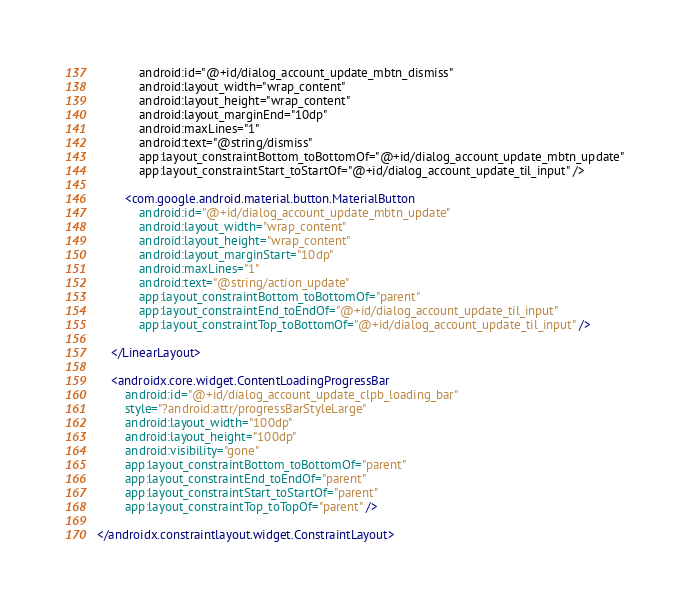Convert code to text. <code><loc_0><loc_0><loc_500><loc_500><_XML_>            android:id="@+id/dialog_account_update_mbtn_dismiss"
            android:layout_width="wrap_content"
            android:layout_height="wrap_content"
            android:layout_marginEnd="10dp"
            android:maxLines="1"
            android:text="@string/dismiss"
            app:layout_constraintBottom_toBottomOf="@+id/dialog_account_update_mbtn_update"
            app:layout_constraintStart_toStartOf="@+id/dialog_account_update_til_input" />

        <com.google.android.material.button.MaterialButton
            android:id="@+id/dialog_account_update_mbtn_update"
            android:layout_width="wrap_content"
            android:layout_height="wrap_content"
            android:layout_marginStart="10dp"
            android:maxLines="1"
            android:text="@string/action_update"
            app:layout_constraintBottom_toBottomOf="parent"
            app:layout_constraintEnd_toEndOf="@+id/dialog_account_update_til_input"
            app:layout_constraintTop_toBottomOf="@+id/dialog_account_update_til_input" />

    </LinearLayout>

    <androidx.core.widget.ContentLoadingProgressBar
        android:id="@+id/dialog_account_update_clpb_loading_bar"
        style="?android:attr/progressBarStyleLarge"
        android:layout_width="100dp"
        android:layout_height="100dp"
        android:visibility="gone"
        app:layout_constraintBottom_toBottomOf="parent"
        app:layout_constraintEnd_toEndOf="parent"
        app:layout_constraintStart_toStartOf="parent"
        app:layout_constraintTop_toTopOf="parent" />

</androidx.constraintlayout.widget.ConstraintLayout></code> 